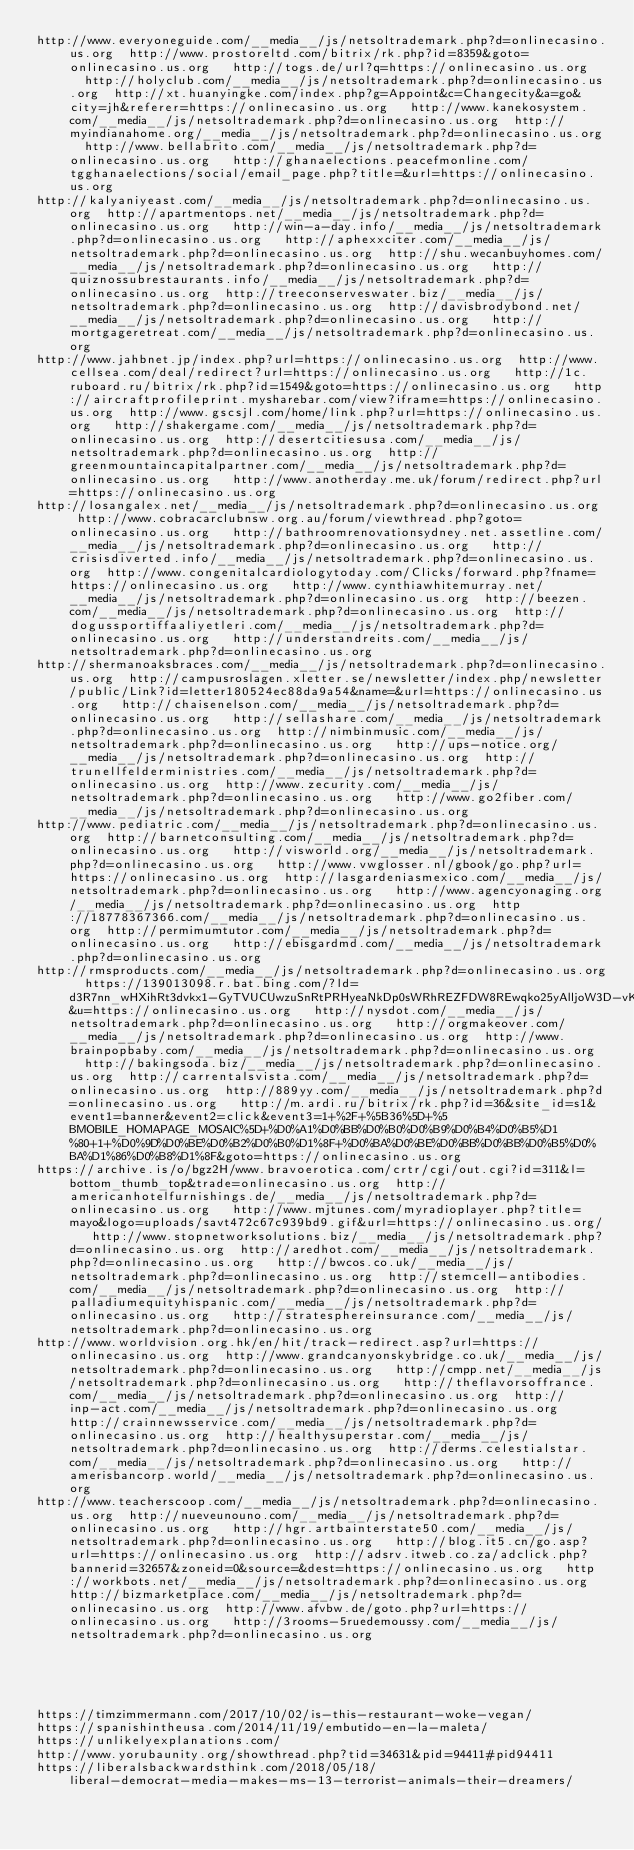<code> <loc_0><loc_0><loc_500><loc_500><_Lisp_>http://www.everyoneguide.com/__media__/js/netsoltrademark.php?d=onlinecasino.us.org  http://www.prostoreltd.com/bitrix/rk.php?id=8359&goto=onlinecasino.us.org   http://togs.de/url?q=https://onlinecasino.us.org   http://holyclub.com/__media__/js/netsoltrademark.php?d=onlinecasino.us.org  http://xt.huanyingke.com/index.php?g=Appoint&c=Changecity&a=go&city=jh&referer=https://onlinecasino.us.org   http://www.kanekosystem.com/__media__/js/netsoltrademark.php?d=onlinecasino.us.org  http://myindianahome.org/__media__/js/netsoltrademark.php?d=onlinecasino.us.org  http://www.bellabrito.com/__media__/js/netsoltrademark.php?d=onlinecasino.us.org   http://ghanaelections.peacefmonline.com/tgghanaelections/social/email_page.php?title=&url=https://onlinecasino.us.org 
http://kalyaniyeast.com/__media__/js/netsoltrademark.php?d=onlinecasino.us.org  http://apartmentops.net/__media__/js/netsoltrademark.php?d=onlinecasino.us.org   http://win-a-day.info/__media__/js/netsoltrademark.php?d=onlinecasino.us.org   http://aphexxciter.com/__media__/js/netsoltrademark.php?d=onlinecasino.us.org  http://shu.wecanbuyhomes.com/__media__/js/netsoltrademark.php?d=onlinecasino.us.org   http://quiznossubrestaurants.info/__media__/js/netsoltrademark.php?d=onlinecasino.us.org  http://treeconserveswater.biz/__media__/js/netsoltrademark.php?d=onlinecasino.us.org  http://davisbrodybond.net/__media__/js/netsoltrademark.php?d=onlinecasino.us.org   http://mortgageretreat.com/__media__/js/netsoltrademark.php?d=onlinecasino.us.org 
http://www.jahbnet.jp/index.php?url=https://onlinecasino.us.org  http://www.cellsea.com/deal/redirect?url=https://onlinecasino.us.org   http://1c.ruboard.ru/bitrix/rk.php?id=1549&goto=https://onlinecasino.us.org   http://aircraftprofileprint.mysharebar.com/view?iframe=https://onlinecasino.us.org  http://www.gscsjl.com/home/link.php?url=https://onlinecasino.us.org   http://shakergame.com/__media__/js/netsoltrademark.php?d=onlinecasino.us.org  http://desertcitiesusa.com/__media__/js/netsoltrademark.php?d=onlinecasino.us.org  http://greenmountaincapitalpartner.com/__media__/js/netsoltrademark.php?d=onlinecasino.us.org   http://www.anotherday.me.uk/forum/redirect.php?url=https://onlinecasino.us.org 
http://losangalex.net/__media__/js/netsoltrademark.php?d=onlinecasino.us.org  http://www.cobracarclubnsw.org.au/forum/viewthread.php?goto=onlinecasino.us.org   http://bathroomrenovationsydney.net.assetline.com/__media__/js/netsoltrademark.php?d=onlinecasino.us.org   http://crisisdiverted.info/__media__/js/netsoltrademark.php?d=onlinecasino.us.org  http://www.congenitalcardiologytoday.com/Clicks/forward.php?fname=https://onlinecasino.us.org   http://www.cynthiawhitemurray.net/__media__/js/netsoltrademark.php?d=onlinecasino.us.org  http://beezen.com/__media__/js/netsoltrademark.php?d=onlinecasino.us.org  http://dogussportiffaaliyetleri.com/__media__/js/netsoltrademark.php?d=onlinecasino.us.org   http://understandreits.com/__media__/js/netsoltrademark.php?d=onlinecasino.us.org 
http://shermanoaksbraces.com/__media__/js/netsoltrademark.php?d=onlinecasino.us.org  http://campusroslagen.xletter.se/newsletter/index.php/newsletter/public/Link?id=letter180524ec88da9a54&name=&url=https://onlinecasino.us.org   http://chaisenelson.com/__media__/js/netsoltrademark.php?d=onlinecasino.us.org   http://sellashare.com/__media__/js/netsoltrademark.php?d=onlinecasino.us.org  http://nimbinmusic.com/__media__/js/netsoltrademark.php?d=onlinecasino.us.org   http://ups-notice.org/__media__/js/netsoltrademark.php?d=onlinecasino.us.org  http://trunellfelderministries.com/__media__/js/netsoltrademark.php?d=onlinecasino.us.org  http://www.zecurity.com/__media__/js/netsoltrademark.php?d=onlinecasino.us.org   http://www.go2fiber.com/__media__/js/netsoltrademark.php?d=onlinecasino.us.org 
http://www.pediatric.com/__media__/js/netsoltrademark.php?d=onlinecasino.us.org  http://barnetconsulting.com/__media__/js/netsoltrademark.php?d=onlinecasino.us.org   http://visworld.org/__media__/js/netsoltrademark.php?d=onlinecasino.us.org   http://www.vwglosser.nl/gbook/go.php?url=https://onlinecasino.us.org  http://lasgardeniasmexico.com/__media__/js/netsoltrademark.php?d=onlinecasino.us.org   http://www.agencyonaging.org/__media__/js/netsoltrademark.php?d=onlinecasino.us.org  http://18778367366.com/__media__/js/netsoltrademark.php?d=onlinecasino.us.org  http://permimumtutor.com/__media__/js/netsoltrademark.php?d=onlinecasino.us.org   http://ebisgardmd.com/__media__/js/netsoltrademark.php?d=onlinecasino.us.org 
http://rmsproducts.com/__media__/js/netsoltrademark.php?d=onlinecasino.us.org  https://139013098.r.bat.bing.com/?ld=d3R7nn_wHXihRt3dvkx1-GyTVUCUwzuSnRtPRHyeaNkDp0sWRhREZFDW8REwqko25yAlljoW3D-vKe-XTl34KGY9V6AfZURJmiR8qHafYUF4MoMyMO1N6zCqes6MiiL8nmMe_CVjGxen_EgUvWEjLZum56DSU&u=https://onlinecasino.us.org   http://nysdot.com/__media__/js/netsoltrademark.php?d=onlinecasino.us.org   http://orgmakeover.com/__media__/js/netsoltrademark.php?d=onlinecasino.us.org  http://www.brainpopbaby.com/__media__/js/netsoltrademark.php?d=onlinecasino.us.org   http://bakingsoda.biz/__media__/js/netsoltrademark.php?d=onlinecasino.us.org  http://carrentalsvista.com/__media__/js/netsoltrademark.php?d=onlinecasino.us.org  http://889yy.com/__media__/js/netsoltrademark.php?d=onlinecasino.us.org   http://m.ardi.ru/bitrix/rk.php?id=36&site_id=s1&event1=banner&event2=click&event3=1+%2F+%5B36%5D+%5BMOBILE_HOMAPAGE_MOSAIC%5D+%D0%A1%D0%BB%D0%B0%D0%B9%D0%B4%D0%B5%D1%80+1+%D0%9D%D0%BE%D0%B2%D0%B0%D1%8F+%D0%BA%D0%BE%D0%BB%D0%BB%D0%B5%D0%BA%D1%86%D0%B8%D1%8F&goto=https://onlinecasino.us.org 
https://archive.is/o/bgz2H/www.bravoerotica.com/crtr/cgi/out.cgi?id=311&l=bottom_thumb_top&trade=onlinecasino.us.org  http://americanhotelfurnishings.de/__media__/js/netsoltrademark.php?d=onlinecasino.us.org   http://www.mjtunes.com/myradioplayer.php?title=mayo&logo=uploads/savt472c67c939bd9.gif&url=https://onlinecasino.us.org/   http://www.stopnetworksolutions.biz/__media__/js/netsoltrademark.php?d=onlinecasino.us.org  http://aredhot.com/__media__/js/netsoltrademark.php?d=onlinecasino.us.org   http://bwcos.co.uk/__media__/js/netsoltrademark.php?d=onlinecasino.us.org  http://stemcell-antibodies.com/__media__/js/netsoltrademark.php?d=onlinecasino.us.org  http://palladiumequityhispanic.com/__media__/js/netsoltrademark.php?d=onlinecasino.us.org   http://stratesphereinsurance.com/__media__/js/netsoltrademark.php?d=onlinecasino.us.org 
http://www.worldvision.org.hk/en/hit/track-redirect.asp?url=https://onlinecasino.us.org  http://www.grandcanyonskybridge.co.uk/__media__/js/netsoltrademark.php?d=onlinecasino.us.org   http://cmpp.net/__media__/js/netsoltrademark.php?d=onlinecasino.us.org   http://theflavorsoffrance.com/__media__/js/netsoltrademark.php?d=onlinecasino.us.org  http://inp-act.com/__media__/js/netsoltrademark.php?d=onlinecasino.us.org   http://crainnewsservice.com/__media__/js/netsoltrademark.php?d=onlinecasino.us.org  http://healthysuperstar.com/__media__/js/netsoltrademark.php?d=onlinecasino.us.org  http://derms.celestialstar.com/__media__/js/netsoltrademark.php?d=onlinecasino.us.org   http://amerisbancorp.world/__media__/js/netsoltrademark.php?d=onlinecasino.us.org 
http://www.teacherscoop.com/__media__/js/netsoltrademark.php?d=onlinecasino.us.org  http://nueveunouno.com/__media__/js/netsoltrademark.php?d=onlinecasino.us.org   http://hgr.artbainterstate50.com/__media__/js/netsoltrademark.php?d=onlinecasino.us.org   http://blog.it5.cn/go.asp?url=https://onlinecasino.us.org  http://adsrv.itweb.co.za/adclick.php?bannerid=32657&zoneid=0&source=&dest=https://onlinecasino.us.org   http://workbots.net/__media__/js/netsoltrademark.php?d=onlinecasino.us.org  http://bizmarketplace.com/__media__/js/netsoltrademark.php?d=onlinecasino.us.org  http://www.afvbw.de/goto.php?url=https://onlinecasino.us.org   http://3rooms-5ruedemoussy.com/__media__/js/netsoltrademark.php?d=onlinecasino.us.org 
 
 
 
 
 
https://timzimmermann.com/2017/10/02/is-this-restaurant-woke-vegan/
https://spanishintheusa.com/2014/11/19/embutido-en-la-maleta/
https://unlikelyexplanations.com/
http://www.yorubaunity.org/showthread.php?tid=34631&pid=94411#pid94411
https://liberalsbackwardsthink.com/2018/05/18/liberal-democrat-media-makes-ms-13-terrorist-animals-their-dreamers/
</code> 